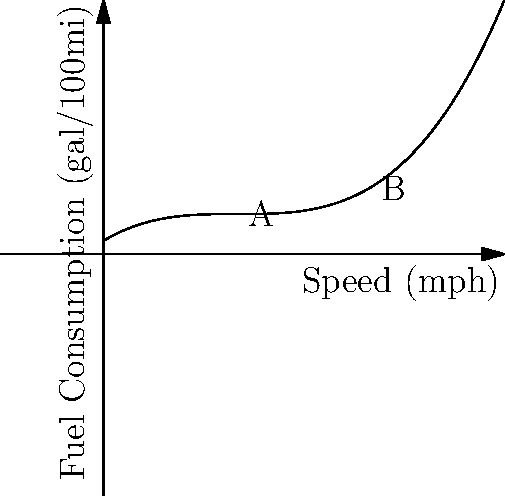The graph represents the relationship between a motorcycle's speed and fuel consumption. Point A represents fuel consumption at 20 mph, and point B at 40 mph. If the fuel consumption at 20 mph is 8 gal/100mi, what is the approximate fuel consumption at 40 mph? To solve this problem, we need to analyze the graph and use the given information:

1. Point A represents fuel consumption at 20 mph, which is given as 8 gal/100mi.
2. Point B represents fuel consumption at 40 mph, which we need to find.
3. The graph shows a polynomial relationship between speed and fuel consumption.

To estimate the fuel consumption at 40 mph:

1. Observe that the curve is not linear, but the change is relatively smooth.
2. The vertical distance from the x-axis to point B appears to be about 1.5 times the distance to point A.
3. Since point A represents 8 gal/100mi, we can estimate point B as:

   $8 \times 1.5 = 12$ gal/100mi

Therefore, the approximate fuel consumption at 40 mph is 12 gal/100mi.
Answer: 12 gal/100mi 